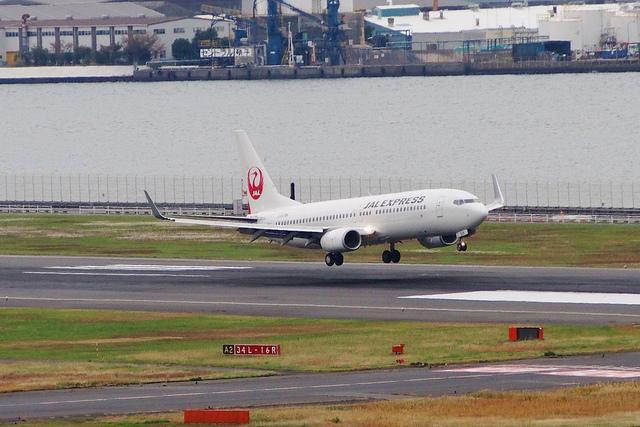Has the plane lifted off the ground?
Quick response, please. Yes. Is the planes engine running?
Short answer required. Yes. Is this a passenger jet?
Be succinct. Yes. What number is printed on the tail?
Concise answer only. 7. 